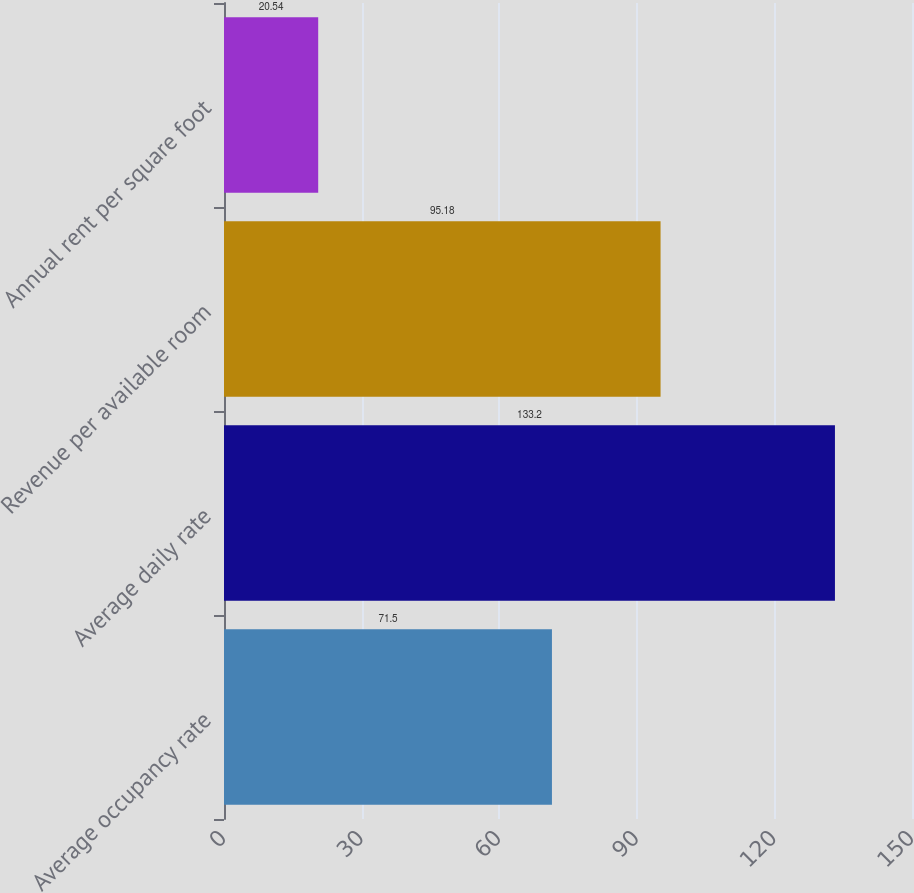Convert chart to OTSL. <chart><loc_0><loc_0><loc_500><loc_500><bar_chart><fcel>Average occupancy rate<fcel>Average daily rate<fcel>Revenue per available room<fcel>Annual rent per square foot<nl><fcel>71.5<fcel>133.2<fcel>95.18<fcel>20.54<nl></chart> 